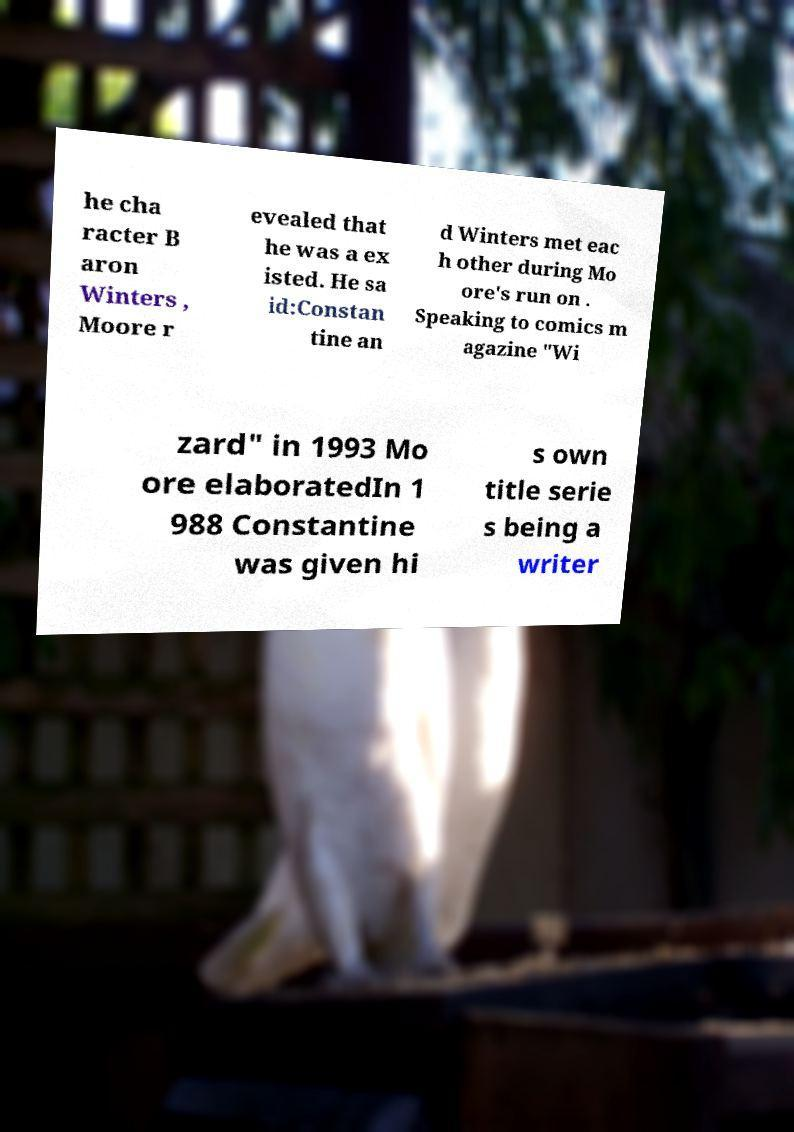Please identify and transcribe the text found in this image. he cha racter B aron Winters , Moore r evealed that he was a ex isted. He sa id:Constan tine an d Winters met eac h other during Mo ore's run on . Speaking to comics m agazine "Wi zard" in 1993 Mo ore elaboratedIn 1 988 Constantine was given hi s own title serie s being a writer 